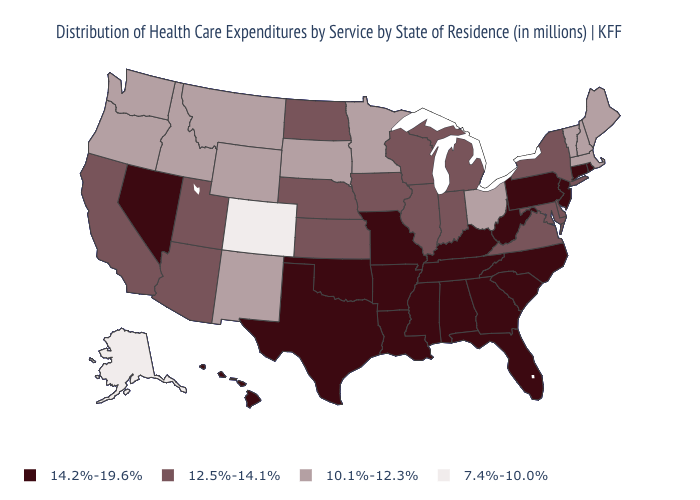Name the states that have a value in the range 14.2%-19.6%?
Short answer required. Alabama, Arkansas, Connecticut, Florida, Georgia, Hawaii, Kentucky, Louisiana, Mississippi, Missouri, Nevada, New Jersey, North Carolina, Oklahoma, Pennsylvania, Rhode Island, South Carolina, Tennessee, Texas, West Virginia. How many symbols are there in the legend?
Concise answer only. 4. How many symbols are there in the legend?
Short answer required. 4. Does the first symbol in the legend represent the smallest category?
Give a very brief answer. No. Does Hawaii have the highest value in the West?
Be succinct. Yes. Name the states that have a value in the range 14.2%-19.6%?
Concise answer only. Alabama, Arkansas, Connecticut, Florida, Georgia, Hawaii, Kentucky, Louisiana, Mississippi, Missouri, Nevada, New Jersey, North Carolina, Oklahoma, Pennsylvania, Rhode Island, South Carolina, Tennessee, Texas, West Virginia. Name the states that have a value in the range 10.1%-12.3%?
Give a very brief answer. Idaho, Maine, Massachusetts, Minnesota, Montana, New Hampshire, New Mexico, Ohio, Oregon, South Dakota, Vermont, Washington, Wyoming. Name the states that have a value in the range 12.5%-14.1%?
Short answer required. Arizona, California, Delaware, Illinois, Indiana, Iowa, Kansas, Maryland, Michigan, Nebraska, New York, North Dakota, Utah, Virginia, Wisconsin. What is the value of New Hampshire?
Give a very brief answer. 10.1%-12.3%. Does the map have missing data?
Short answer required. No. Does the first symbol in the legend represent the smallest category?
Answer briefly. No. Is the legend a continuous bar?
Write a very short answer. No. Among the states that border Delaware , does New Jersey have the highest value?
Quick response, please. Yes. 